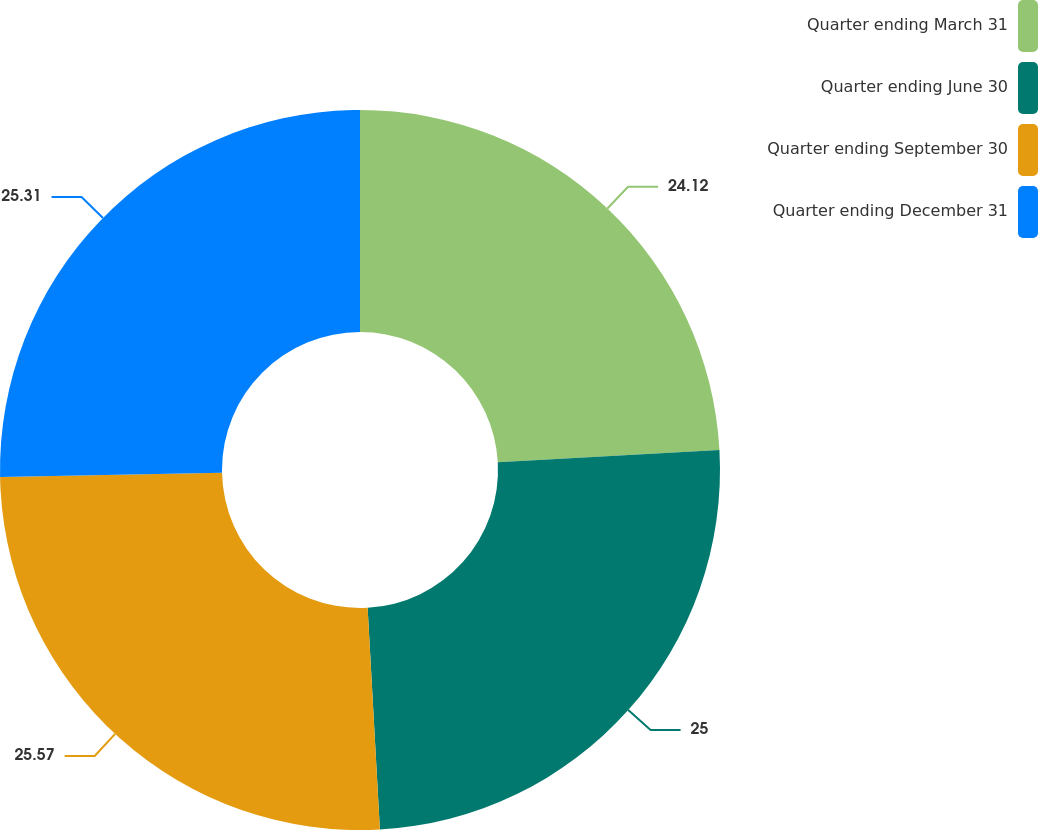<chart> <loc_0><loc_0><loc_500><loc_500><pie_chart><fcel>Quarter ending March 31<fcel>Quarter ending June 30<fcel>Quarter ending September 30<fcel>Quarter ending December 31<nl><fcel>24.12%<fcel>25.0%<fcel>25.57%<fcel>25.31%<nl></chart> 